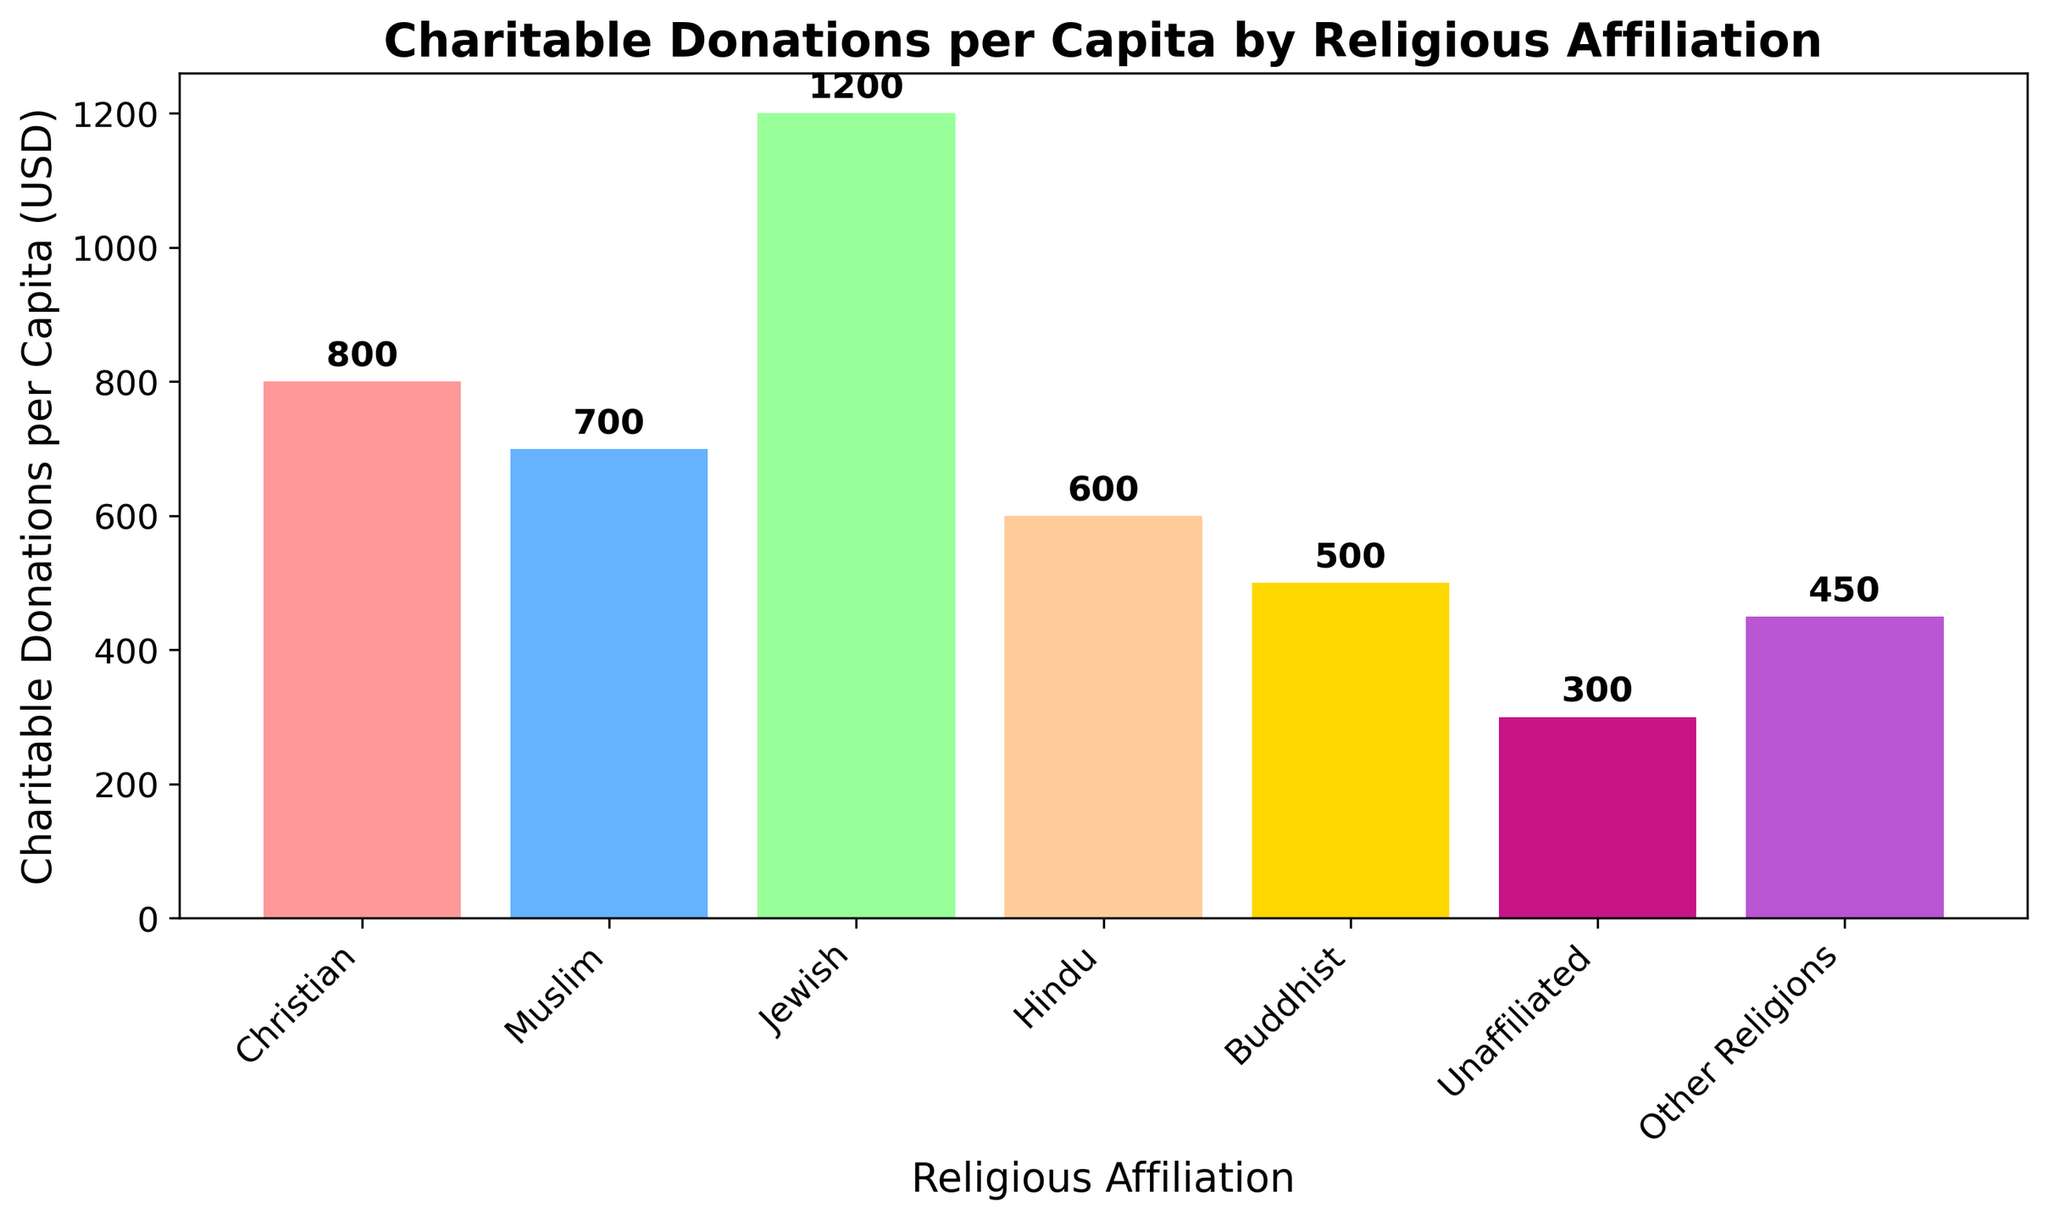What religious affiliation has the highest charitable donations per capita? The figure shows a bar for each religious affiliation. By finding the tallest bar, we can identify the religious group with the highest donations. The "Jewish" bar is the highest.
Answer: Jewish What is the total charitable donation per capita for Buddhist and Muslim combined? To find the total, add the charitable donations per capita for both Buddhists (500 USD) and Muslims (700 USD). The sum is 500 + 700.
Answer: 1200 USD How does the charitable donation per capita for Christians compare to Hindus? The figure shows the height of each bar. The Christian bar is about 800 USD, and the Hindu bar is about 600 USD. So, Christians donate more per capita than Hindus.
Answer: Christians donate more Which group has the lowest charitable donations per capita? By examining the heights of all bars, the "Unaffiliated" group has the lowest bar at 300 USD.
Answer: Unaffiliated What is the average charitable donation per capita across all the groups? First, sum all the donations: 800 (Christian) + 700 (Muslim) + 1200 (Jewish) + 600 (Hindu) + 500 (Buddhist) + 300 (Unaffiliated) + 450 (Other Religions) = 4550 USD. Then divide by the number of groups: 4550 / 7.
Answer: 650 USD Which two religious groups have the closest charitable donations per capita amounts? By comparing the bars, "Buddhist" and "Other Religions" have donations of 500 USD and 450 USD, respectively, which are closest in value.
Answer: Buddhist and Other Religions What’s the difference in charitable donations per capita between the highest and the lowest groups? The "Jewish" group has the highest donations at 1200 USD, and the "Unaffiliated" group has the lowest at 300 USD. The difference is 1200 - 300.
Answer: 900 USD If the charitable donations for Muslims increased by 10%, what would be the new donation amount? A 10% increase in 700 USD is calculated as (10/100) * 700 = 70 USD. Adding this to the original amount: 700 + 70.
Answer: 770 USD What percentage of the average charitable donation per capita does the Buddhist donation represent? The Buddhist donation is 500 USD. The average donation is 650 USD. The percentage is calculated as (500/650) * 100.
Answer: Approximately 76.9% What are the colors of the bars representing the highest and lowest donations? The highest donation (Jewish) bar is colored blue and the lowest donation (Unaffiliated) bar is colored dark pink.
Answer: Blue and dark pink 